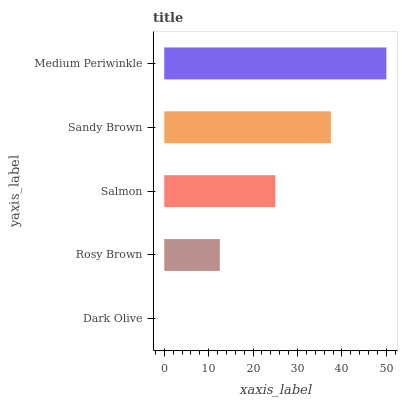Is Dark Olive the minimum?
Answer yes or no. Yes. Is Medium Periwinkle the maximum?
Answer yes or no. Yes. Is Rosy Brown the minimum?
Answer yes or no. No. Is Rosy Brown the maximum?
Answer yes or no. No. Is Rosy Brown greater than Dark Olive?
Answer yes or no. Yes. Is Dark Olive less than Rosy Brown?
Answer yes or no. Yes. Is Dark Olive greater than Rosy Brown?
Answer yes or no. No. Is Rosy Brown less than Dark Olive?
Answer yes or no. No. Is Salmon the high median?
Answer yes or no. Yes. Is Salmon the low median?
Answer yes or no. Yes. Is Sandy Brown the high median?
Answer yes or no. No. Is Sandy Brown the low median?
Answer yes or no. No. 